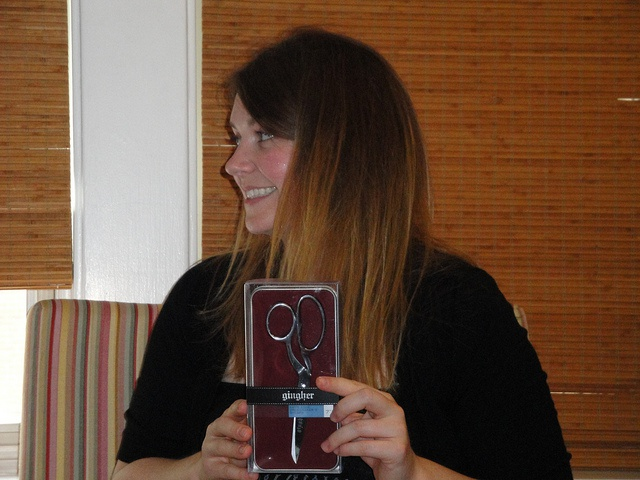Describe the objects in this image and their specific colors. I can see people in maroon, black, and gray tones, chair in maroon, gray, and tan tones, and scissors in maroon, black, and gray tones in this image. 